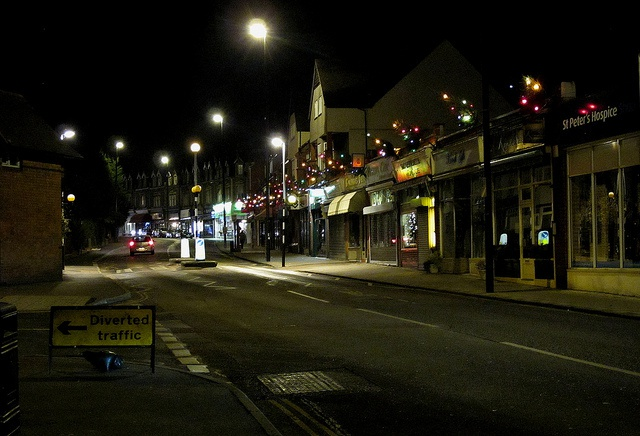Describe the objects in this image and their specific colors. I can see car in black, maroon, gray, and olive tones, people in black, gray, and darkgreen tones, and car in black, gray, darkgray, and lightgray tones in this image. 